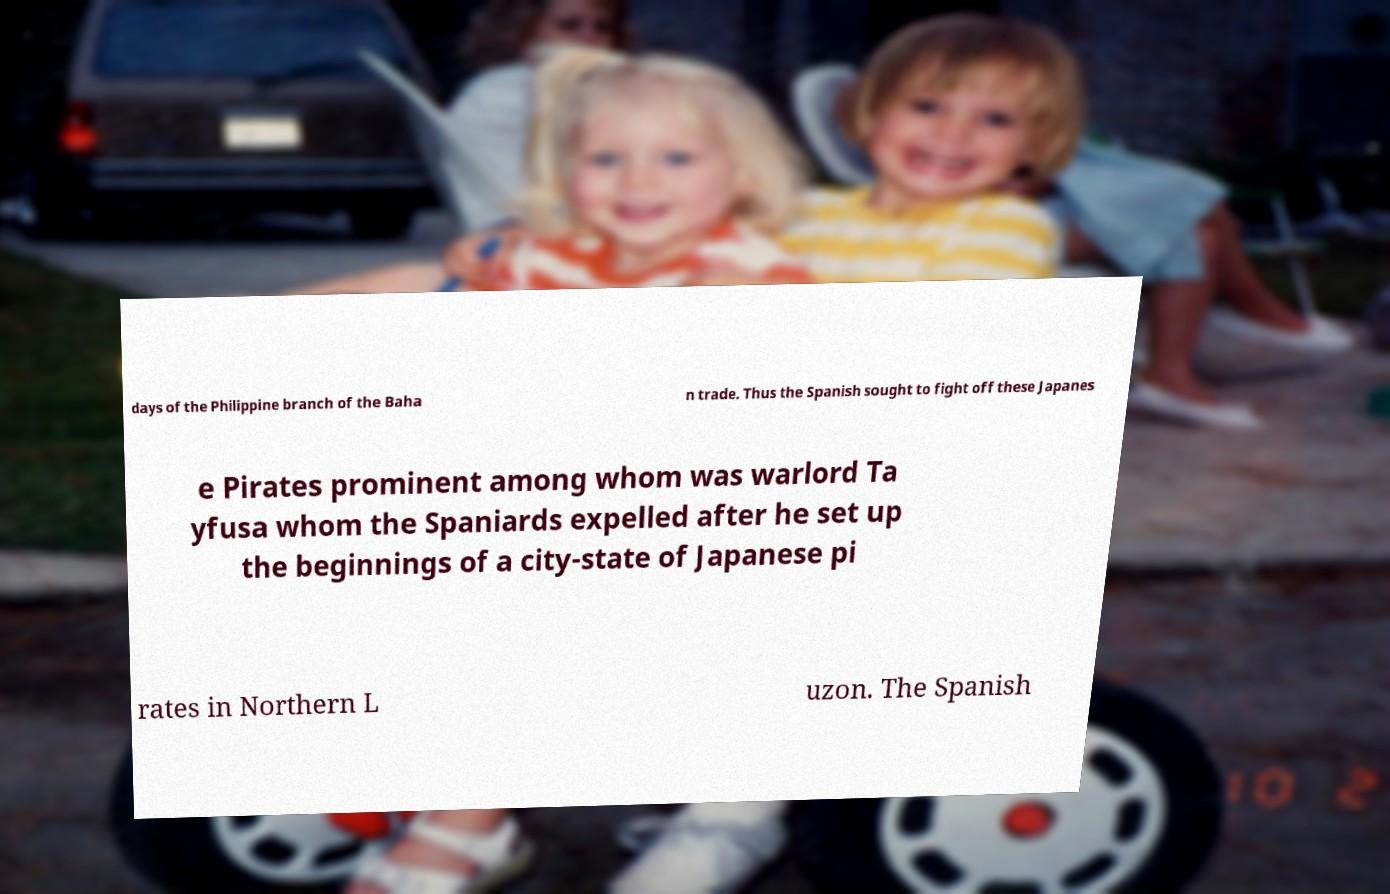Please read and relay the text visible in this image. What does it say? days of the Philippine branch of the Baha n trade. Thus the Spanish sought to fight off these Japanes e Pirates prominent among whom was warlord Ta yfusa whom the Spaniards expelled after he set up the beginnings of a city-state of Japanese pi rates in Northern L uzon. The Spanish 